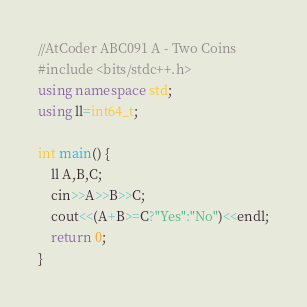Convert code to text. <code><loc_0><loc_0><loc_500><loc_500><_C++_>//AtCoder ABC091 A - Two Coins
#include <bits/stdc++.h>
using namespace std;
using ll=int64_t;

int main() {
    ll A,B,C;
    cin>>A>>B>>C;
    cout<<(A+B>=C?"Yes":"No")<<endl;
    return 0;
}</code> 